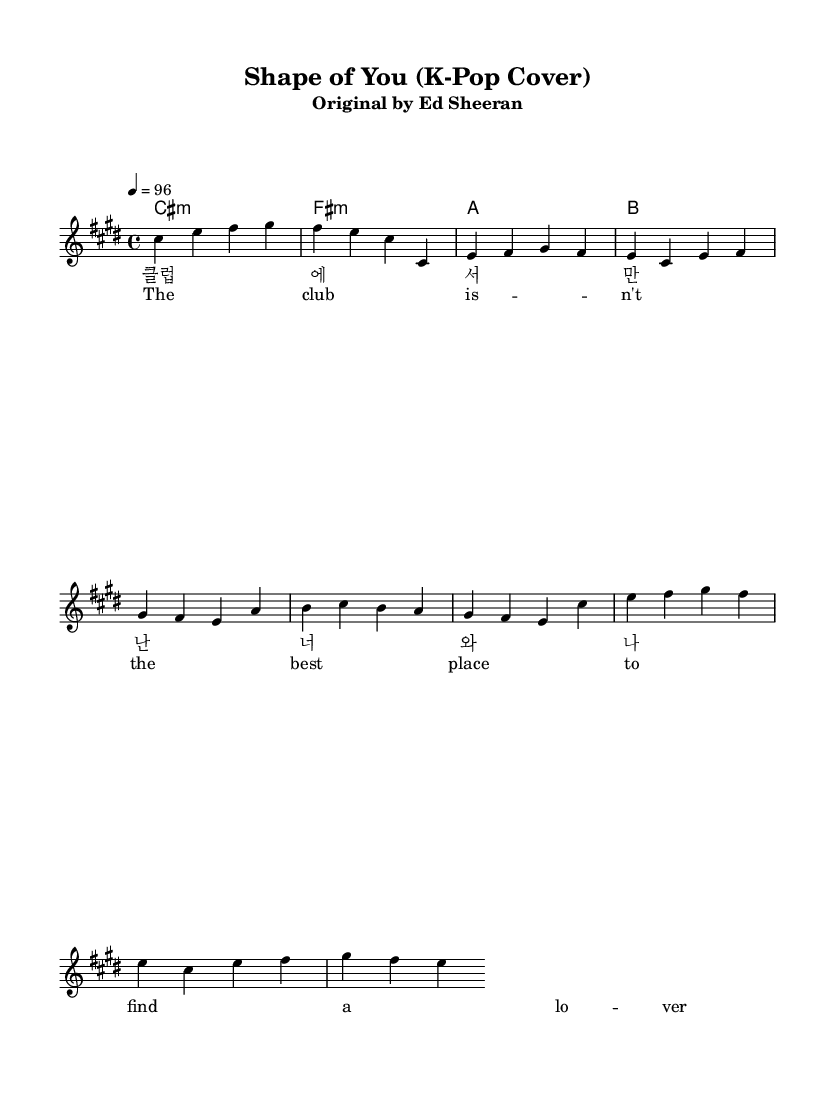What is the key signature of this music? The key signature is indicated at the beginning of the score, which shows a flat or sharp symbol. In this case, it indicates C sharp minor, as it has four sharps (C#, D#, E, F#, G#, A, B).
Answer: C sharp minor What is the time signature of the music? The time signature is found at the start of the piece, displayed as a fraction. Here, it is shown as 4/4, which indicates there are four beats in each measure.
Answer: 4/4 What is the tempo marking in the music? The tempo marking is located near the top of the score and indicates the speed of the performance. This score states a tempo of 96 beats per minute.
Answer: 96 How many measures are in the verse section? By counting the measures written for the verse in the score, we can determine the number. The verse consists of two repetitions that contain a total of 6 measures.
Answer: 6 What is the primary language in the lyrics? The lyrics are presented in two lines: one in Korean and one in English. However, the majority of verses are in Korean, indicating that the primary language featured is Korean.
Answer: Korean Which part of the song contains the phrase "I'm in love with the shape of you"? This specific phrase appears in the chorus section of the song. The chorus is marked separately, and the English lyrics include this line.
Answer: Chorus What unique aspect does the blend of Korean and English lyrics reflect in this K-Pop cover? The blending of Korean and English in the lyrics showcases the global appeal of K-Pop by making the song accessible to a wider audience and reflecting its cultural fusion.
Answer: Cultural fusion 